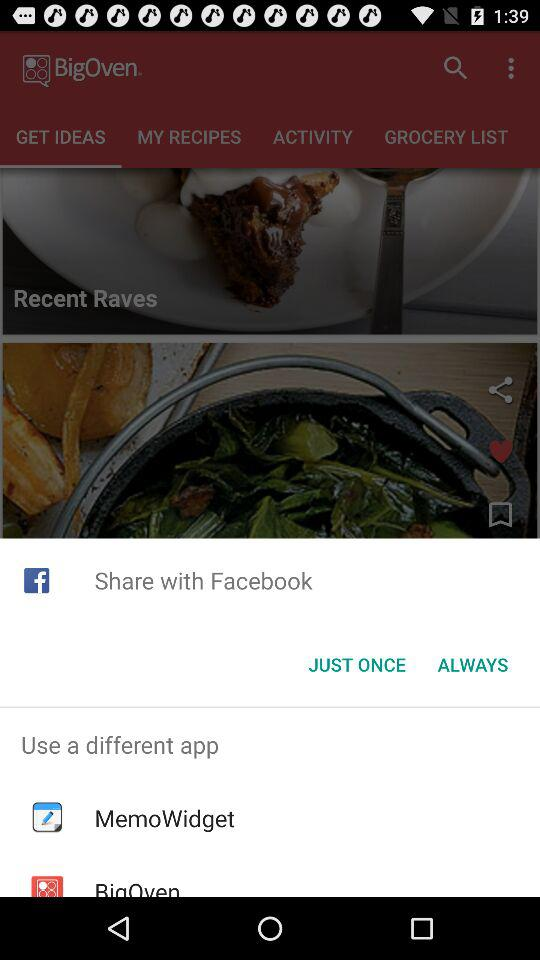With which account can content be shared? Content can be shared with "Facebook" and "MemoWidget". 